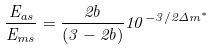<formula> <loc_0><loc_0><loc_500><loc_500>\frac { E _ { a s } } { E _ { m s } } = \frac { 2 b } { ( 3 - 2 b ) } 1 0 ^ { - 3 / 2 \Delta m ^ { * } }</formula> 